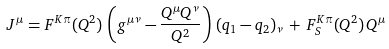Convert formula to latex. <formula><loc_0><loc_0><loc_500><loc_500>J ^ { \mu } = F ^ { K \pi } ( Q ^ { 2 } ) \, \left ( g ^ { \mu \nu } - \frac { Q ^ { \mu } Q ^ { \nu } } { Q ^ { 2 } } \right ) \, ( q _ { 1 } - q _ { 2 } ) _ { \nu } \, + \, F _ { S } ^ { K \pi } ( Q ^ { 2 } ) \, Q ^ { \mu }</formula> 